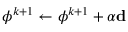<formula> <loc_0><loc_0><loc_500><loc_500>\phi ^ { k + 1 } \leftarrow \phi ^ { k + 1 } + \alpha d</formula> 